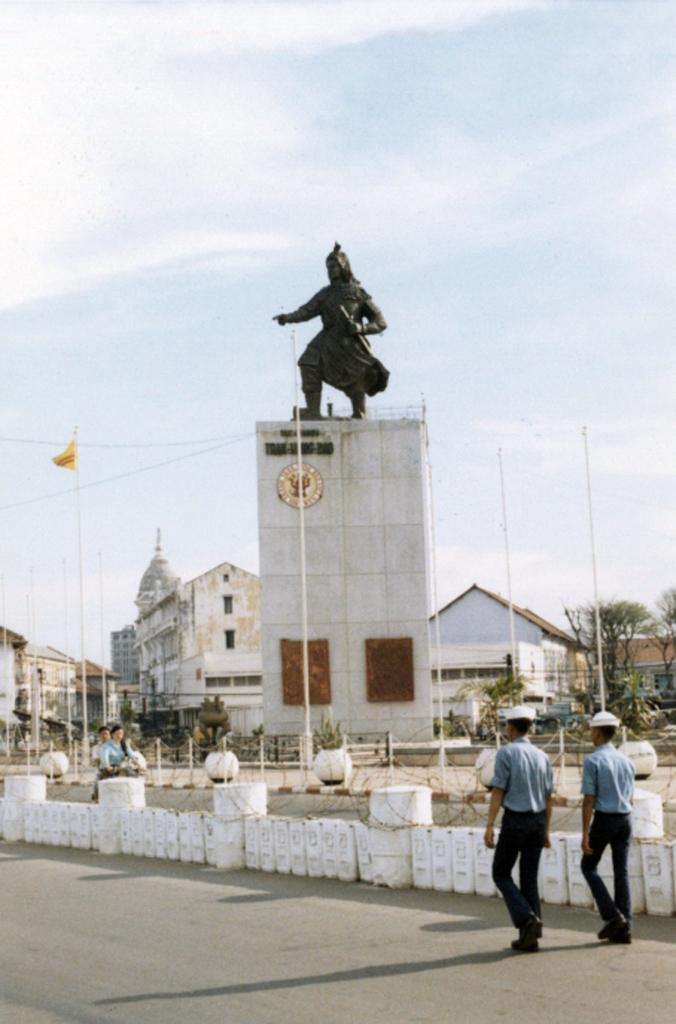Could you give a brief overview of what you see in this image? This image is clicked on the road. There are two men walking on the road. On the other side of the road there are two persons. Beside the road there is a railing. In the background there are buildings. In the center there is a building and on the building there is a sculpture. There are trees and poles in the image. To the left there is a flag to a pole. At the top there is the sky. 